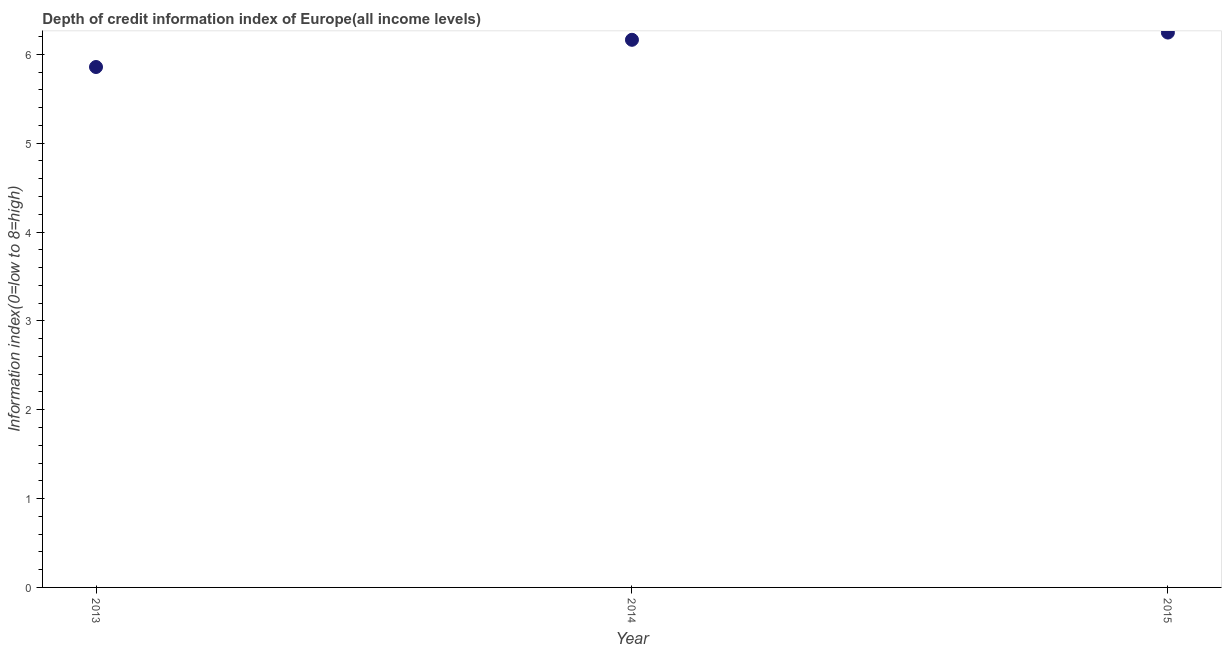What is the depth of credit information index in 2015?
Your answer should be very brief. 6.24. Across all years, what is the maximum depth of credit information index?
Make the answer very short. 6.24. Across all years, what is the minimum depth of credit information index?
Ensure brevity in your answer.  5.86. In which year was the depth of credit information index maximum?
Your response must be concise. 2015. What is the sum of the depth of credit information index?
Offer a very short reply. 18.27. What is the difference between the depth of credit information index in 2014 and 2015?
Provide a succinct answer. -0.08. What is the average depth of credit information index per year?
Give a very brief answer. 6.09. What is the median depth of credit information index?
Provide a succinct answer. 6.16. Do a majority of the years between 2015 and 2013 (inclusive) have depth of credit information index greater than 2.6 ?
Your response must be concise. No. What is the ratio of the depth of credit information index in 2014 to that in 2015?
Your response must be concise. 0.99. Is the depth of credit information index in 2013 less than that in 2014?
Offer a very short reply. Yes. Is the difference between the depth of credit information index in 2013 and 2014 greater than the difference between any two years?
Your answer should be compact. No. What is the difference between the highest and the second highest depth of credit information index?
Provide a short and direct response. 0.08. Is the sum of the depth of credit information index in 2013 and 2014 greater than the maximum depth of credit information index across all years?
Give a very brief answer. Yes. What is the difference between the highest and the lowest depth of credit information index?
Provide a succinct answer. 0.39. What is the title of the graph?
Make the answer very short. Depth of credit information index of Europe(all income levels). What is the label or title of the X-axis?
Your response must be concise. Year. What is the label or title of the Y-axis?
Your response must be concise. Information index(0=low to 8=high). What is the Information index(0=low to 8=high) in 2013?
Your answer should be compact. 5.86. What is the Information index(0=low to 8=high) in 2014?
Your answer should be very brief. 6.16. What is the Information index(0=low to 8=high) in 2015?
Keep it short and to the point. 6.24. What is the difference between the Information index(0=low to 8=high) in 2013 and 2014?
Offer a terse response. -0.31. What is the difference between the Information index(0=low to 8=high) in 2013 and 2015?
Offer a very short reply. -0.39. What is the difference between the Information index(0=low to 8=high) in 2014 and 2015?
Your answer should be very brief. -0.08. What is the ratio of the Information index(0=low to 8=high) in 2013 to that in 2015?
Your answer should be compact. 0.94. 